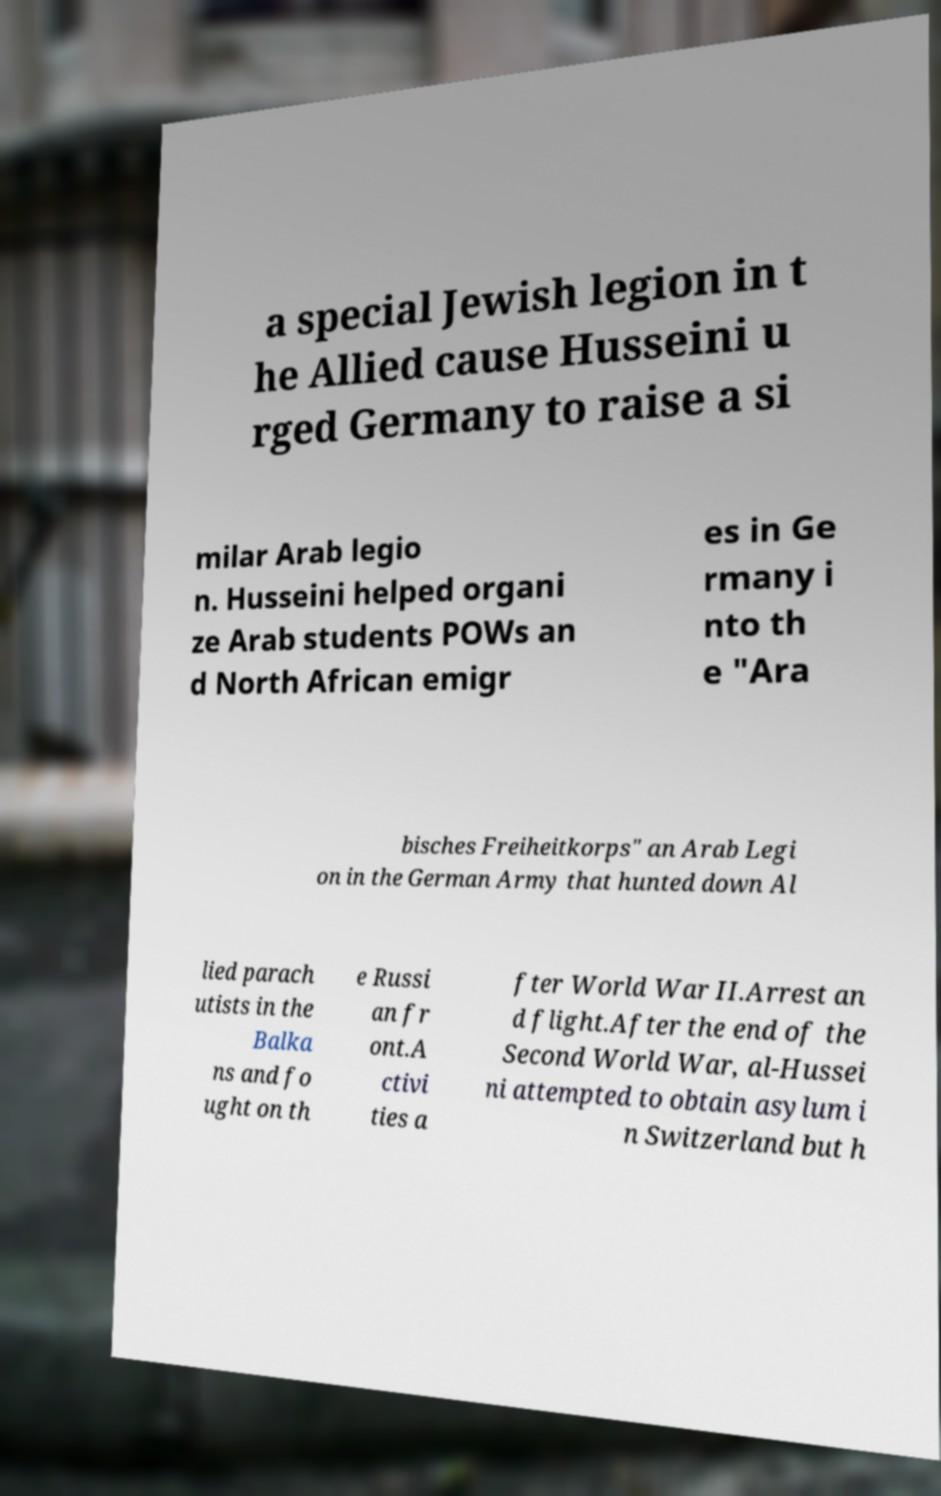Can you read and provide the text displayed in the image?This photo seems to have some interesting text. Can you extract and type it out for me? a special Jewish legion in t he Allied cause Husseini u rged Germany to raise a si milar Arab legio n. Husseini helped organi ze Arab students POWs an d North African emigr es in Ge rmany i nto th e "Ara bisches Freiheitkorps" an Arab Legi on in the German Army that hunted down Al lied parach utists in the Balka ns and fo ught on th e Russi an fr ont.A ctivi ties a fter World War II.Arrest an d flight.After the end of the Second World War, al-Hussei ni attempted to obtain asylum i n Switzerland but h 